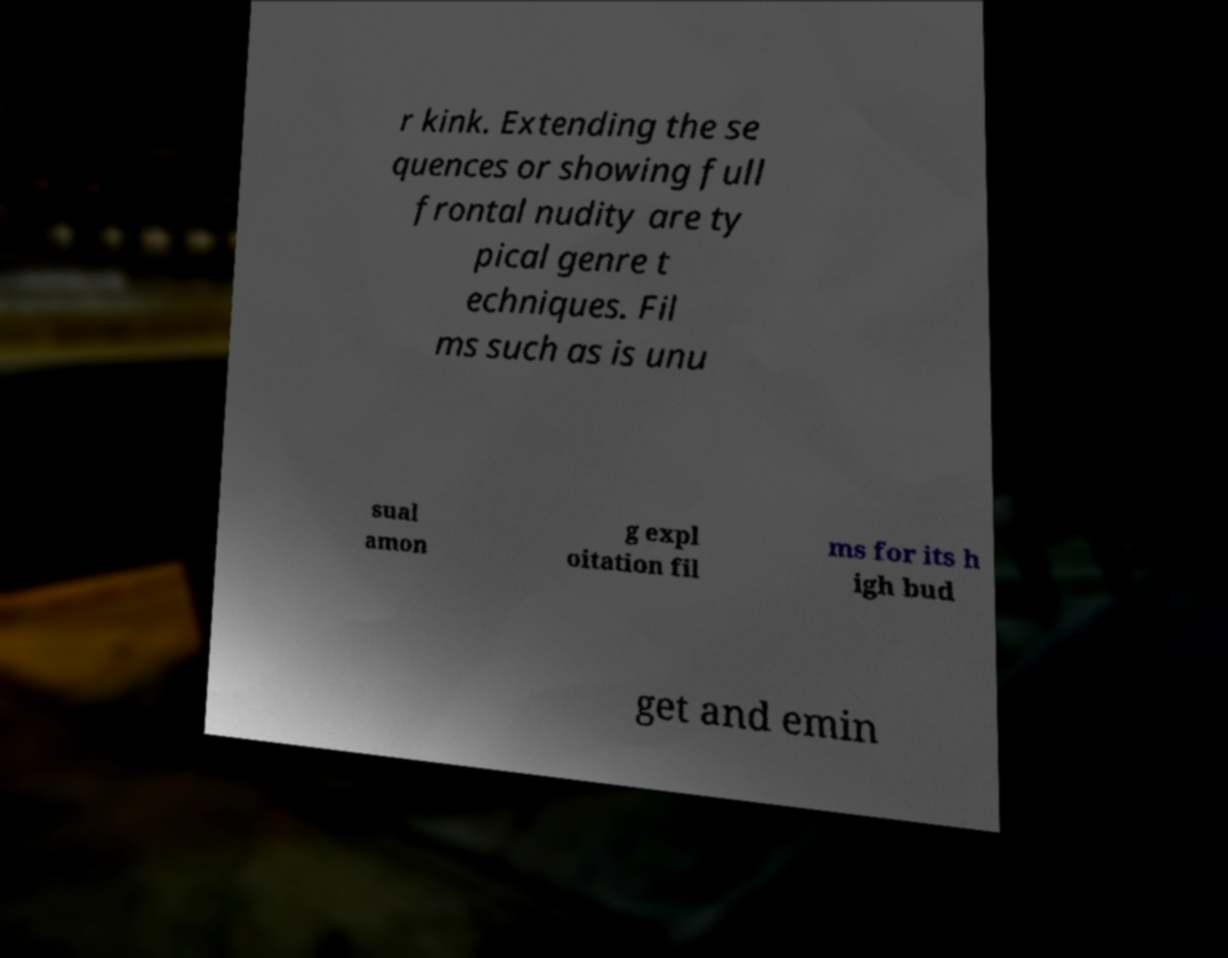There's text embedded in this image that I need extracted. Can you transcribe it verbatim? r kink. Extending the se quences or showing full frontal nudity are ty pical genre t echniques. Fil ms such as is unu sual amon g expl oitation fil ms for its h igh bud get and emin 